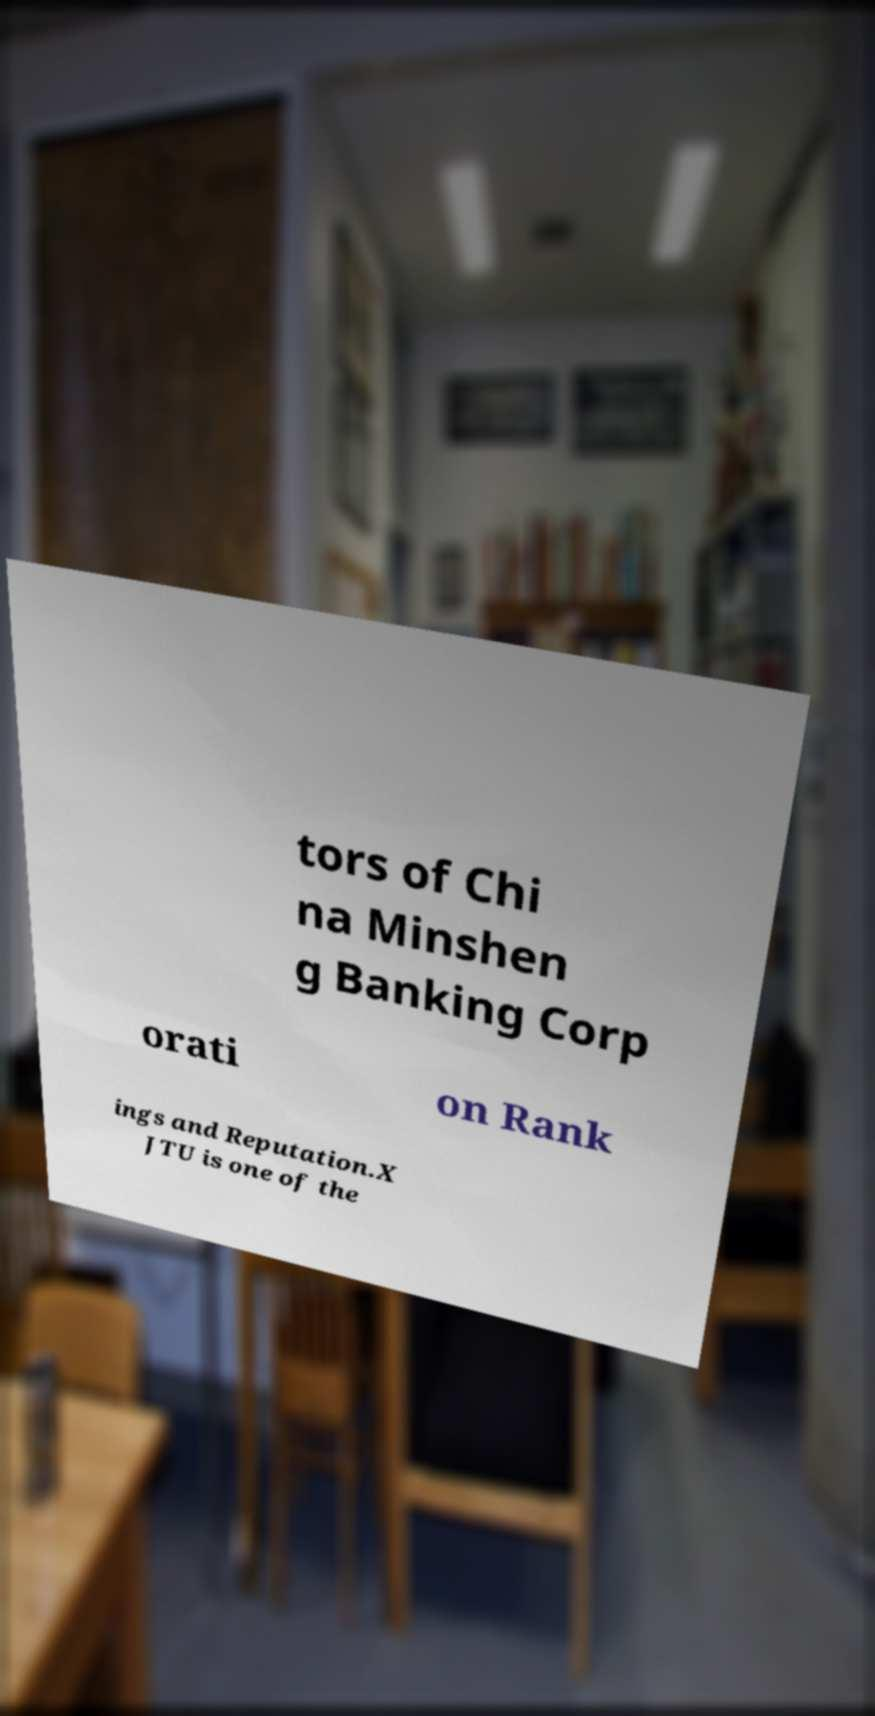Please read and relay the text visible in this image. What does it say? tors of Chi na Minshen g Banking Corp orati on Rank ings and Reputation.X JTU is one of the 